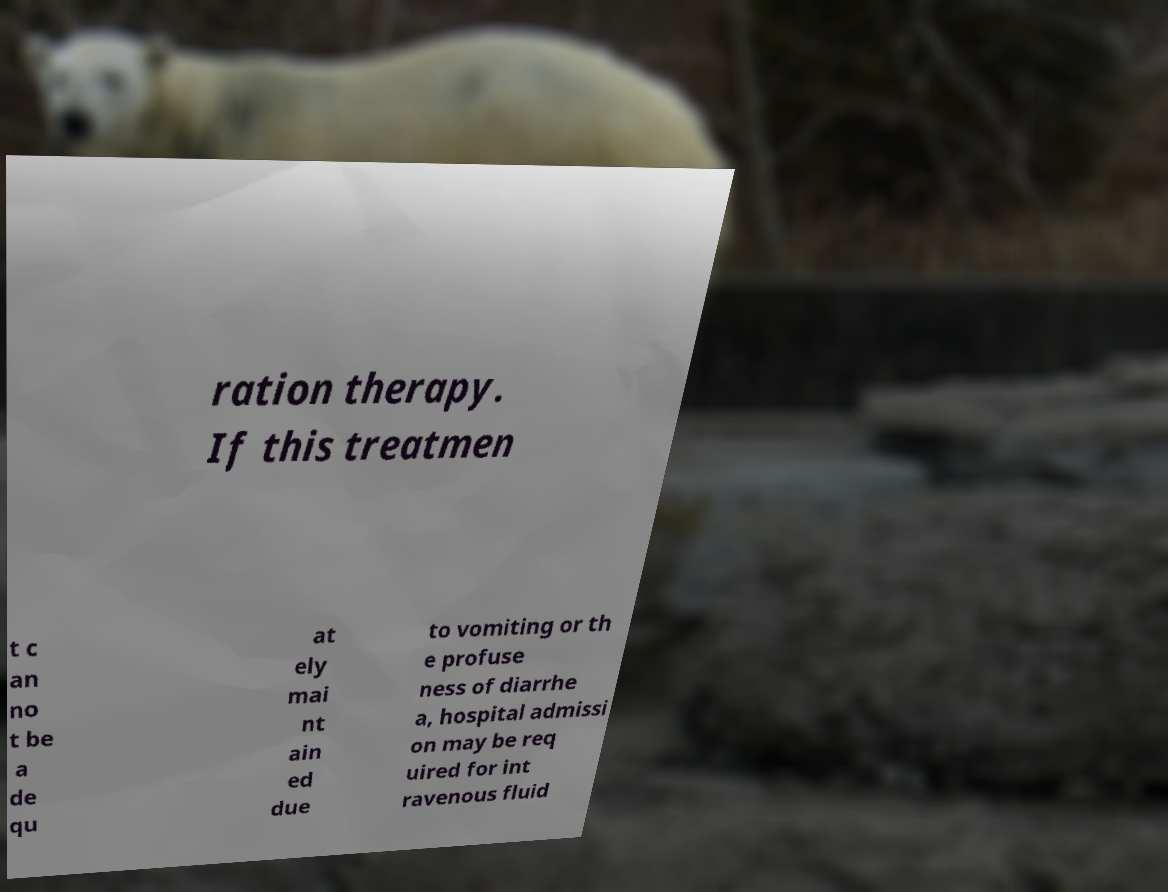Please read and relay the text visible in this image. What does it say? ration therapy. If this treatmen t c an no t be a de qu at ely mai nt ain ed due to vomiting or th e profuse ness of diarrhe a, hospital admissi on may be req uired for int ravenous fluid 